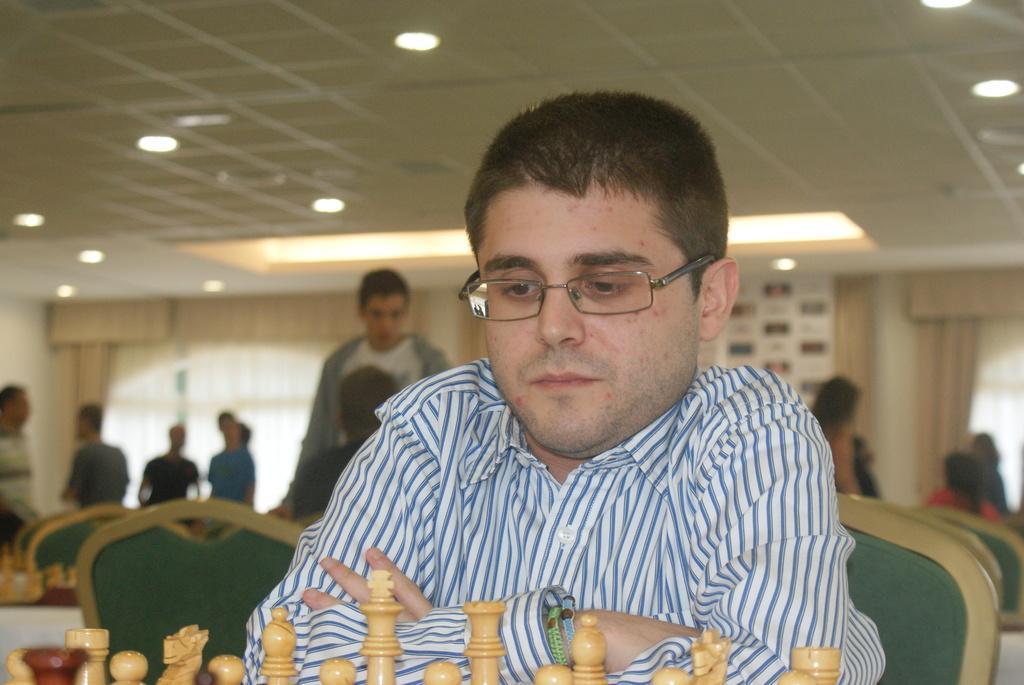Describe this image in one or two sentences. In this image we can see a man sitting on a chair. On the backside we can see some chairs, table and a group of people standing. We can also see a wall, window with a curtain, a board, a person sitting and a roof with some ceiling lights. On the bottom of the image we can see some chess pieces. 